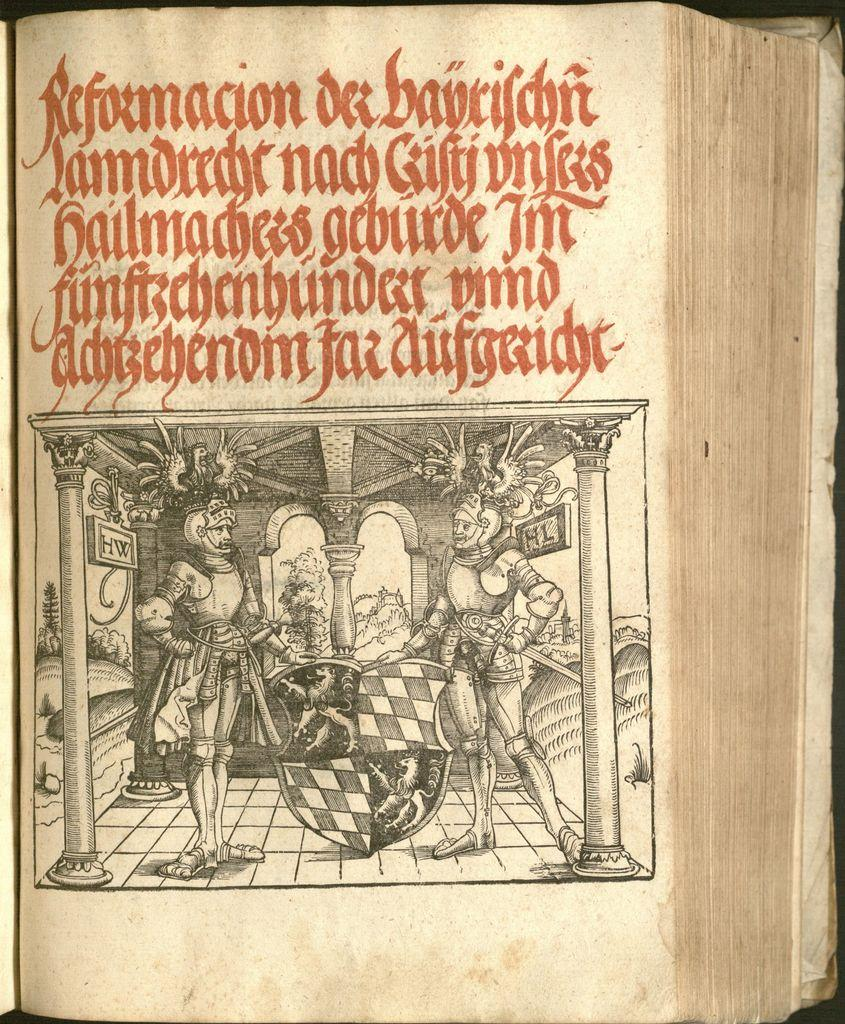<image>
Offer a succinct explanation of the picture presented. An antique book about reformacion is open to scene with two soldiers 